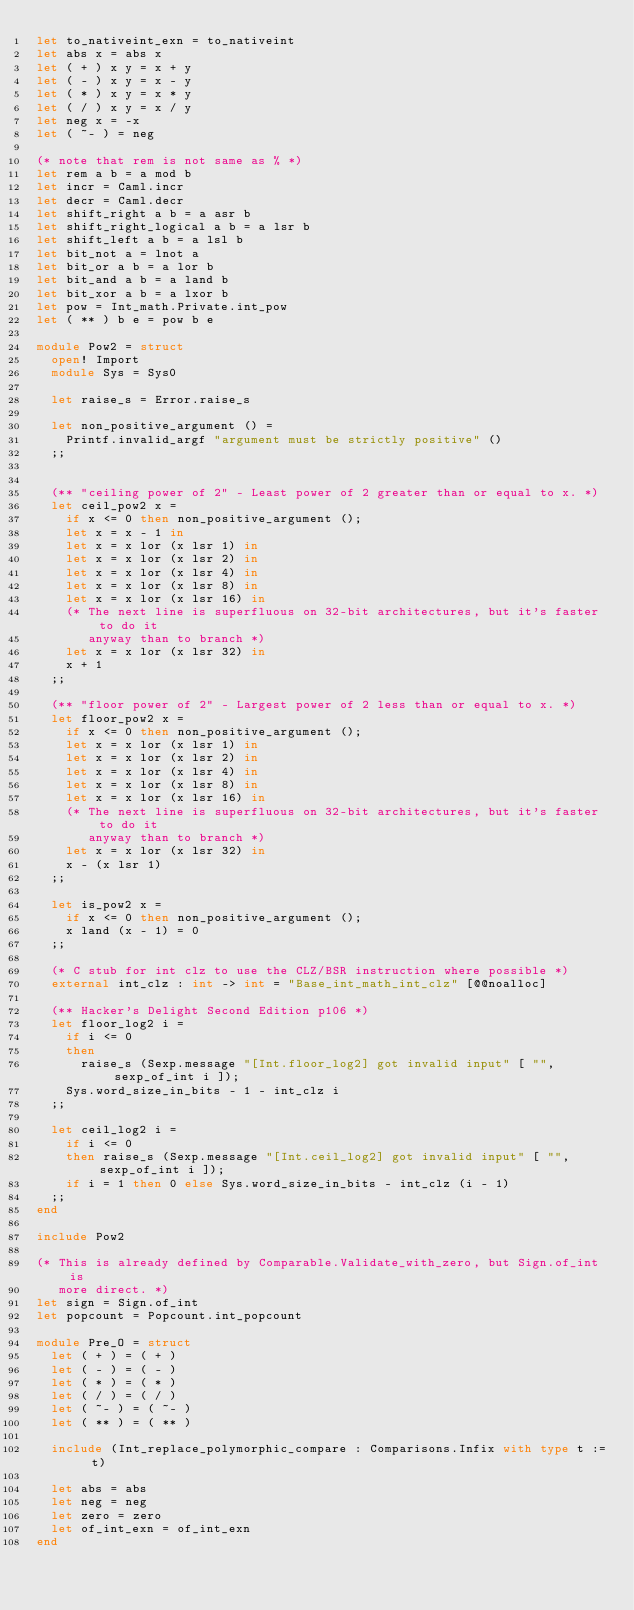Convert code to text. <code><loc_0><loc_0><loc_500><loc_500><_OCaml_>let to_nativeint_exn = to_nativeint
let abs x = abs x
let ( + ) x y = x + y
let ( - ) x y = x - y
let ( * ) x y = x * y
let ( / ) x y = x / y
let neg x = -x
let ( ~- ) = neg

(* note that rem is not same as % *)
let rem a b = a mod b
let incr = Caml.incr
let decr = Caml.decr
let shift_right a b = a asr b
let shift_right_logical a b = a lsr b
let shift_left a b = a lsl b
let bit_not a = lnot a
let bit_or a b = a lor b
let bit_and a b = a land b
let bit_xor a b = a lxor b
let pow = Int_math.Private.int_pow
let ( ** ) b e = pow b e

module Pow2 = struct
  open! Import
  module Sys = Sys0

  let raise_s = Error.raise_s

  let non_positive_argument () =
    Printf.invalid_argf "argument must be strictly positive" ()
  ;;


  (** "ceiling power of 2" - Least power of 2 greater than or equal to x. *)
  let ceil_pow2 x =
    if x <= 0 then non_positive_argument ();
    let x = x - 1 in
    let x = x lor (x lsr 1) in
    let x = x lor (x lsr 2) in
    let x = x lor (x lsr 4) in
    let x = x lor (x lsr 8) in
    let x = x lor (x lsr 16) in
    (* The next line is superfluous on 32-bit architectures, but it's faster to do it
       anyway than to branch *)
    let x = x lor (x lsr 32) in
    x + 1
  ;;

  (** "floor power of 2" - Largest power of 2 less than or equal to x. *)
  let floor_pow2 x =
    if x <= 0 then non_positive_argument ();
    let x = x lor (x lsr 1) in
    let x = x lor (x lsr 2) in
    let x = x lor (x lsr 4) in
    let x = x lor (x lsr 8) in
    let x = x lor (x lsr 16) in
    (* The next line is superfluous on 32-bit architectures, but it's faster to do it
       anyway than to branch *)
    let x = x lor (x lsr 32) in
    x - (x lsr 1)
  ;;

  let is_pow2 x =
    if x <= 0 then non_positive_argument ();
    x land (x - 1) = 0
  ;;

  (* C stub for int clz to use the CLZ/BSR instruction where possible *)
  external int_clz : int -> int = "Base_int_math_int_clz" [@@noalloc]

  (** Hacker's Delight Second Edition p106 *)
  let floor_log2 i =
    if i <= 0
    then
      raise_s (Sexp.message "[Int.floor_log2] got invalid input" [ "", sexp_of_int i ]);
    Sys.word_size_in_bits - 1 - int_clz i
  ;;

  let ceil_log2 i =
    if i <= 0
    then raise_s (Sexp.message "[Int.ceil_log2] got invalid input" [ "", sexp_of_int i ]);
    if i = 1 then 0 else Sys.word_size_in_bits - int_clz (i - 1)
  ;;
end

include Pow2

(* This is already defined by Comparable.Validate_with_zero, but Sign.of_int is
   more direct. *)
let sign = Sign.of_int
let popcount = Popcount.int_popcount

module Pre_O = struct
  let ( + ) = ( + )
  let ( - ) = ( - )
  let ( * ) = ( * )
  let ( / ) = ( / )
  let ( ~- ) = ( ~- )
  let ( ** ) = ( ** )

  include (Int_replace_polymorphic_compare : Comparisons.Infix with type t := t)

  let abs = abs
  let neg = neg
  let zero = zero
  let of_int_exn = of_int_exn
end
</code> 